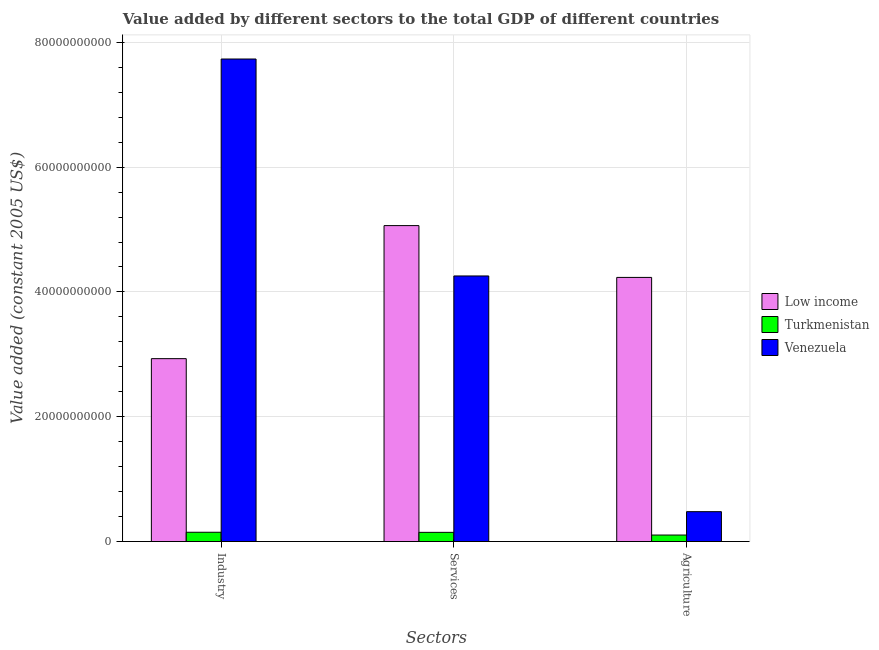How many groups of bars are there?
Offer a terse response. 3. Are the number of bars per tick equal to the number of legend labels?
Your response must be concise. Yes. Are the number of bars on each tick of the X-axis equal?
Make the answer very short. Yes. What is the label of the 3rd group of bars from the left?
Offer a very short reply. Agriculture. What is the value added by services in Turkmenistan?
Provide a succinct answer. 1.47e+09. Across all countries, what is the maximum value added by services?
Offer a very short reply. 5.06e+1. Across all countries, what is the minimum value added by agricultural sector?
Your answer should be very brief. 1.04e+09. In which country was the value added by services minimum?
Your response must be concise. Turkmenistan. What is the total value added by services in the graph?
Provide a succinct answer. 9.47e+1. What is the difference between the value added by services in Venezuela and that in Turkmenistan?
Ensure brevity in your answer.  4.11e+1. What is the difference between the value added by services in Low income and the value added by industrial sector in Venezuela?
Keep it short and to the point. -2.67e+1. What is the average value added by agricultural sector per country?
Your response must be concise. 1.61e+1. What is the difference between the value added by industrial sector and value added by services in Venezuela?
Your answer should be compact. 3.48e+1. In how many countries, is the value added by industrial sector greater than 56000000000 US$?
Make the answer very short. 1. What is the ratio of the value added by industrial sector in Low income to that in Turkmenistan?
Make the answer very short. 19.67. Is the value added by services in Turkmenistan less than that in Low income?
Your response must be concise. Yes. Is the difference between the value added by services in Turkmenistan and Venezuela greater than the difference between the value added by agricultural sector in Turkmenistan and Venezuela?
Ensure brevity in your answer.  No. What is the difference between the highest and the second highest value added by agricultural sector?
Make the answer very short. 3.75e+1. What is the difference between the highest and the lowest value added by services?
Your answer should be very brief. 4.92e+1. Is the sum of the value added by industrial sector in Low income and Turkmenistan greater than the maximum value added by services across all countries?
Provide a succinct answer. No. What does the 2nd bar from the right in Agriculture represents?
Ensure brevity in your answer.  Turkmenistan. How many bars are there?
Your answer should be very brief. 9. How many countries are there in the graph?
Make the answer very short. 3. What is the difference between two consecutive major ticks on the Y-axis?
Your answer should be very brief. 2.00e+1. Does the graph contain any zero values?
Your answer should be compact. No. How many legend labels are there?
Offer a terse response. 3. What is the title of the graph?
Keep it short and to the point. Value added by different sectors to the total GDP of different countries. What is the label or title of the X-axis?
Provide a short and direct response. Sectors. What is the label or title of the Y-axis?
Ensure brevity in your answer.  Value added (constant 2005 US$). What is the Value added (constant 2005 US$) of Low income in Industry?
Give a very brief answer. 2.93e+1. What is the Value added (constant 2005 US$) of Turkmenistan in Industry?
Offer a terse response. 1.49e+09. What is the Value added (constant 2005 US$) of Venezuela in Industry?
Make the answer very short. 7.73e+1. What is the Value added (constant 2005 US$) of Low income in Services?
Provide a short and direct response. 5.06e+1. What is the Value added (constant 2005 US$) in Turkmenistan in Services?
Provide a succinct answer. 1.47e+09. What is the Value added (constant 2005 US$) in Venezuela in Services?
Your answer should be very brief. 4.26e+1. What is the Value added (constant 2005 US$) in Low income in Agriculture?
Ensure brevity in your answer.  4.23e+1. What is the Value added (constant 2005 US$) of Turkmenistan in Agriculture?
Offer a terse response. 1.04e+09. What is the Value added (constant 2005 US$) in Venezuela in Agriculture?
Your answer should be very brief. 4.79e+09. Across all Sectors, what is the maximum Value added (constant 2005 US$) in Low income?
Give a very brief answer. 5.06e+1. Across all Sectors, what is the maximum Value added (constant 2005 US$) in Turkmenistan?
Your response must be concise. 1.49e+09. Across all Sectors, what is the maximum Value added (constant 2005 US$) in Venezuela?
Your answer should be compact. 7.73e+1. Across all Sectors, what is the minimum Value added (constant 2005 US$) in Low income?
Your response must be concise. 2.93e+1. Across all Sectors, what is the minimum Value added (constant 2005 US$) in Turkmenistan?
Your answer should be very brief. 1.04e+09. Across all Sectors, what is the minimum Value added (constant 2005 US$) in Venezuela?
Give a very brief answer. 4.79e+09. What is the total Value added (constant 2005 US$) in Low income in the graph?
Make the answer very short. 1.22e+11. What is the total Value added (constant 2005 US$) of Turkmenistan in the graph?
Provide a short and direct response. 4.01e+09. What is the total Value added (constant 2005 US$) in Venezuela in the graph?
Your response must be concise. 1.25e+11. What is the difference between the Value added (constant 2005 US$) of Low income in Industry and that in Services?
Your answer should be compact. -2.13e+1. What is the difference between the Value added (constant 2005 US$) of Turkmenistan in Industry and that in Services?
Make the answer very short. 1.53e+07. What is the difference between the Value added (constant 2005 US$) in Venezuela in Industry and that in Services?
Make the answer very short. 3.48e+1. What is the difference between the Value added (constant 2005 US$) of Low income in Industry and that in Agriculture?
Ensure brevity in your answer.  -1.30e+1. What is the difference between the Value added (constant 2005 US$) in Turkmenistan in Industry and that in Agriculture?
Offer a very short reply. 4.46e+08. What is the difference between the Value added (constant 2005 US$) of Venezuela in Industry and that in Agriculture?
Offer a terse response. 7.25e+1. What is the difference between the Value added (constant 2005 US$) of Low income in Services and that in Agriculture?
Give a very brief answer. 8.30e+09. What is the difference between the Value added (constant 2005 US$) of Turkmenistan in Services and that in Agriculture?
Give a very brief answer. 4.31e+08. What is the difference between the Value added (constant 2005 US$) in Venezuela in Services and that in Agriculture?
Your response must be concise. 3.78e+1. What is the difference between the Value added (constant 2005 US$) in Low income in Industry and the Value added (constant 2005 US$) in Turkmenistan in Services?
Your answer should be compact. 2.78e+1. What is the difference between the Value added (constant 2005 US$) of Low income in Industry and the Value added (constant 2005 US$) of Venezuela in Services?
Your answer should be very brief. -1.33e+1. What is the difference between the Value added (constant 2005 US$) in Turkmenistan in Industry and the Value added (constant 2005 US$) in Venezuela in Services?
Your answer should be compact. -4.11e+1. What is the difference between the Value added (constant 2005 US$) in Low income in Industry and the Value added (constant 2005 US$) in Turkmenistan in Agriculture?
Provide a short and direct response. 2.83e+1. What is the difference between the Value added (constant 2005 US$) of Low income in Industry and the Value added (constant 2005 US$) of Venezuela in Agriculture?
Provide a short and direct response. 2.45e+1. What is the difference between the Value added (constant 2005 US$) in Turkmenistan in Industry and the Value added (constant 2005 US$) in Venezuela in Agriculture?
Keep it short and to the point. -3.30e+09. What is the difference between the Value added (constant 2005 US$) in Low income in Services and the Value added (constant 2005 US$) in Turkmenistan in Agriculture?
Offer a terse response. 4.96e+1. What is the difference between the Value added (constant 2005 US$) of Low income in Services and the Value added (constant 2005 US$) of Venezuela in Agriculture?
Your answer should be very brief. 4.58e+1. What is the difference between the Value added (constant 2005 US$) in Turkmenistan in Services and the Value added (constant 2005 US$) in Venezuela in Agriculture?
Ensure brevity in your answer.  -3.32e+09. What is the average Value added (constant 2005 US$) in Low income per Sectors?
Keep it short and to the point. 4.08e+1. What is the average Value added (constant 2005 US$) of Turkmenistan per Sectors?
Provide a short and direct response. 1.34e+09. What is the average Value added (constant 2005 US$) in Venezuela per Sectors?
Ensure brevity in your answer.  4.16e+1. What is the difference between the Value added (constant 2005 US$) in Low income and Value added (constant 2005 US$) in Turkmenistan in Industry?
Make the answer very short. 2.78e+1. What is the difference between the Value added (constant 2005 US$) of Low income and Value added (constant 2005 US$) of Venezuela in Industry?
Your response must be concise. -4.80e+1. What is the difference between the Value added (constant 2005 US$) of Turkmenistan and Value added (constant 2005 US$) of Venezuela in Industry?
Give a very brief answer. -7.58e+1. What is the difference between the Value added (constant 2005 US$) in Low income and Value added (constant 2005 US$) in Turkmenistan in Services?
Your response must be concise. 4.92e+1. What is the difference between the Value added (constant 2005 US$) of Low income and Value added (constant 2005 US$) of Venezuela in Services?
Your response must be concise. 8.07e+09. What is the difference between the Value added (constant 2005 US$) in Turkmenistan and Value added (constant 2005 US$) in Venezuela in Services?
Make the answer very short. -4.11e+1. What is the difference between the Value added (constant 2005 US$) in Low income and Value added (constant 2005 US$) in Turkmenistan in Agriculture?
Give a very brief answer. 4.13e+1. What is the difference between the Value added (constant 2005 US$) of Low income and Value added (constant 2005 US$) of Venezuela in Agriculture?
Offer a terse response. 3.75e+1. What is the difference between the Value added (constant 2005 US$) in Turkmenistan and Value added (constant 2005 US$) in Venezuela in Agriculture?
Ensure brevity in your answer.  -3.75e+09. What is the ratio of the Value added (constant 2005 US$) in Low income in Industry to that in Services?
Offer a terse response. 0.58. What is the ratio of the Value added (constant 2005 US$) of Turkmenistan in Industry to that in Services?
Keep it short and to the point. 1.01. What is the ratio of the Value added (constant 2005 US$) of Venezuela in Industry to that in Services?
Offer a terse response. 1.82. What is the ratio of the Value added (constant 2005 US$) of Low income in Industry to that in Agriculture?
Make the answer very short. 0.69. What is the ratio of the Value added (constant 2005 US$) of Turkmenistan in Industry to that in Agriculture?
Give a very brief answer. 1.43. What is the ratio of the Value added (constant 2005 US$) of Venezuela in Industry to that in Agriculture?
Your answer should be very brief. 16.14. What is the ratio of the Value added (constant 2005 US$) of Low income in Services to that in Agriculture?
Give a very brief answer. 1.2. What is the ratio of the Value added (constant 2005 US$) in Turkmenistan in Services to that in Agriculture?
Offer a terse response. 1.41. What is the ratio of the Value added (constant 2005 US$) in Venezuela in Services to that in Agriculture?
Your response must be concise. 8.88. What is the difference between the highest and the second highest Value added (constant 2005 US$) in Low income?
Your answer should be very brief. 8.30e+09. What is the difference between the highest and the second highest Value added (constant 2005 US$) in Turkmenistan?
Offer a very short reply. 1.53e+07. What is the difference between the highest and the second highest Value added (constant 2005 US$) of Venezuela?
Offer a terse response. 3.48e+1. What is the difference between the highest and the lowest Value added (constant 2005 US$) in Low income?
Offer a terse response. 2.13e+1. What is the difference between the highest and the lowest Value added (constant 2005 US$) of Turkmenistan?
Keep it short and to the point. 4.46e+08. What is the difference between the highest and the lowest Value added (constant 2005 US$) of Venezuela?
Your answer should be compact. 7.25e+1. 